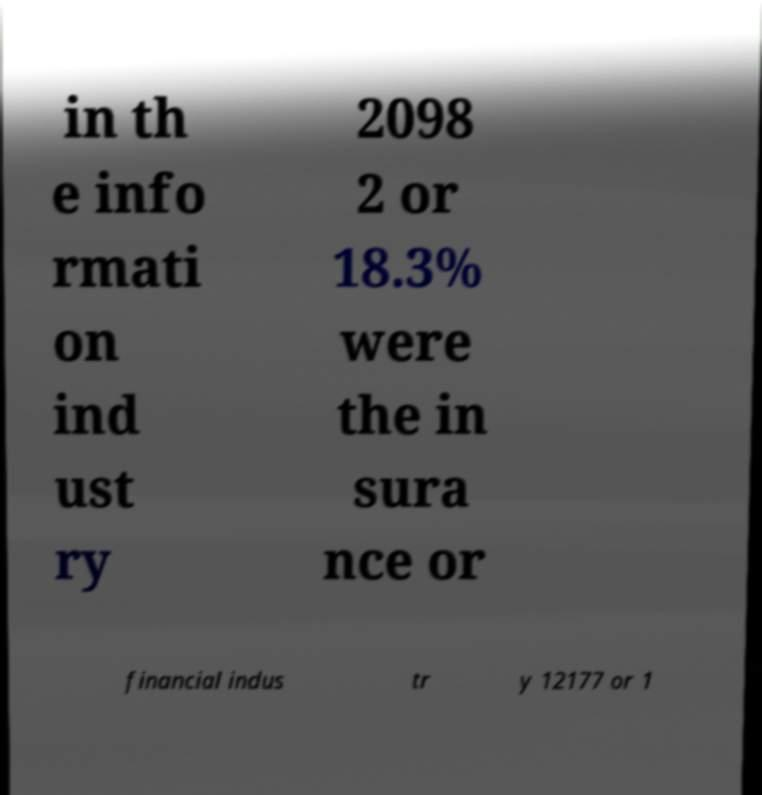Could you extract and type out the text from this image? in th e info rmati on ind ust ry 2098 2 or 18.3% were the in sura nce or financial indus tr y 12177 or 1 